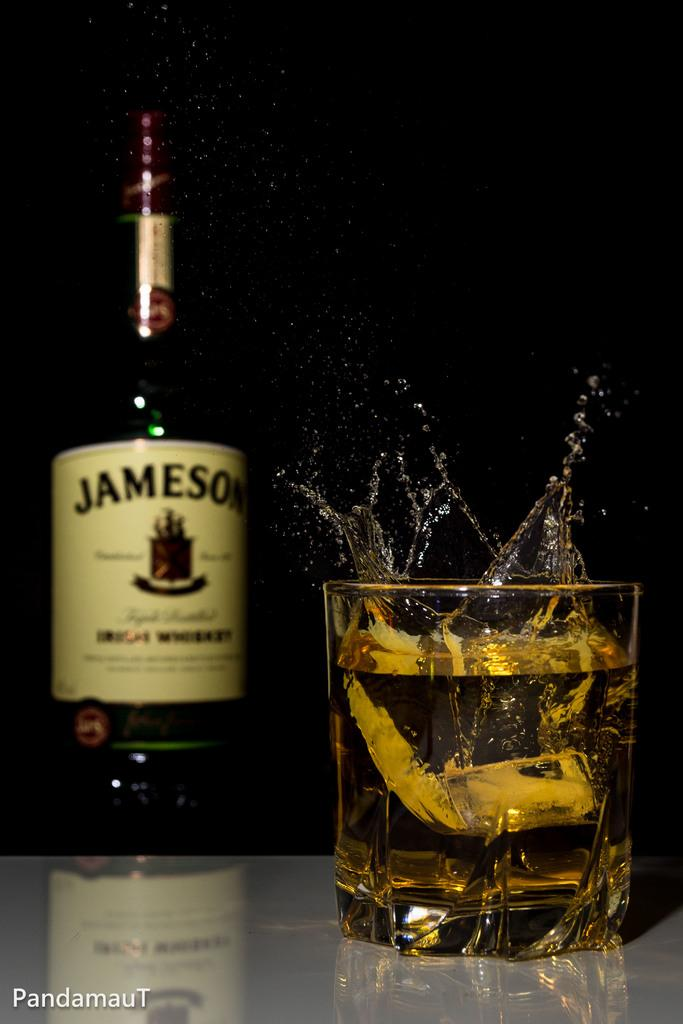<image>
Offer a succinct explanation of the picture presented. A bottle of Jameson and a glass with an ice cube being dropped into it. 